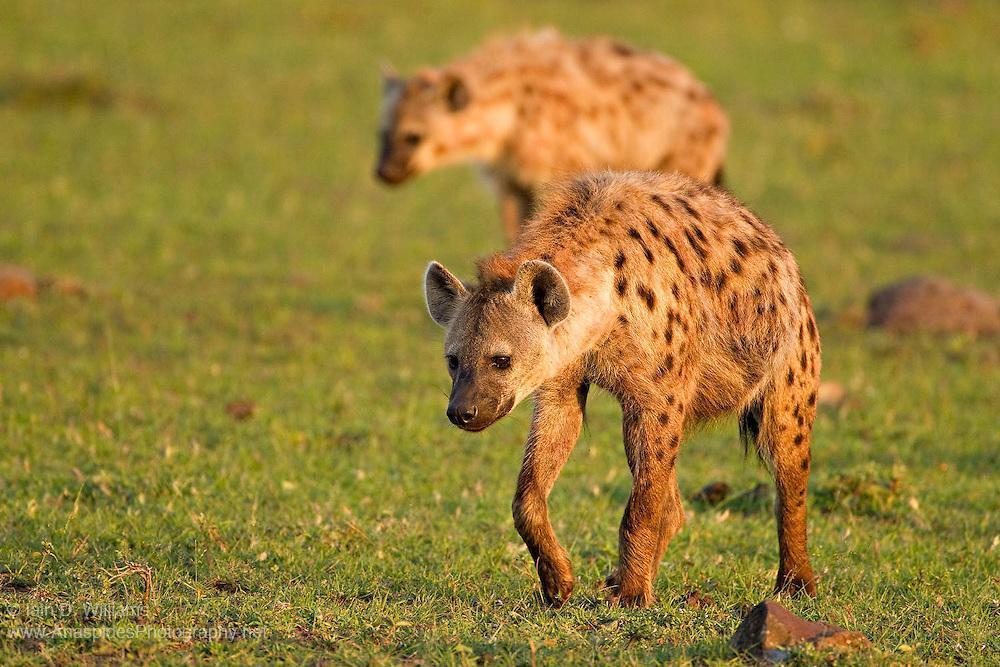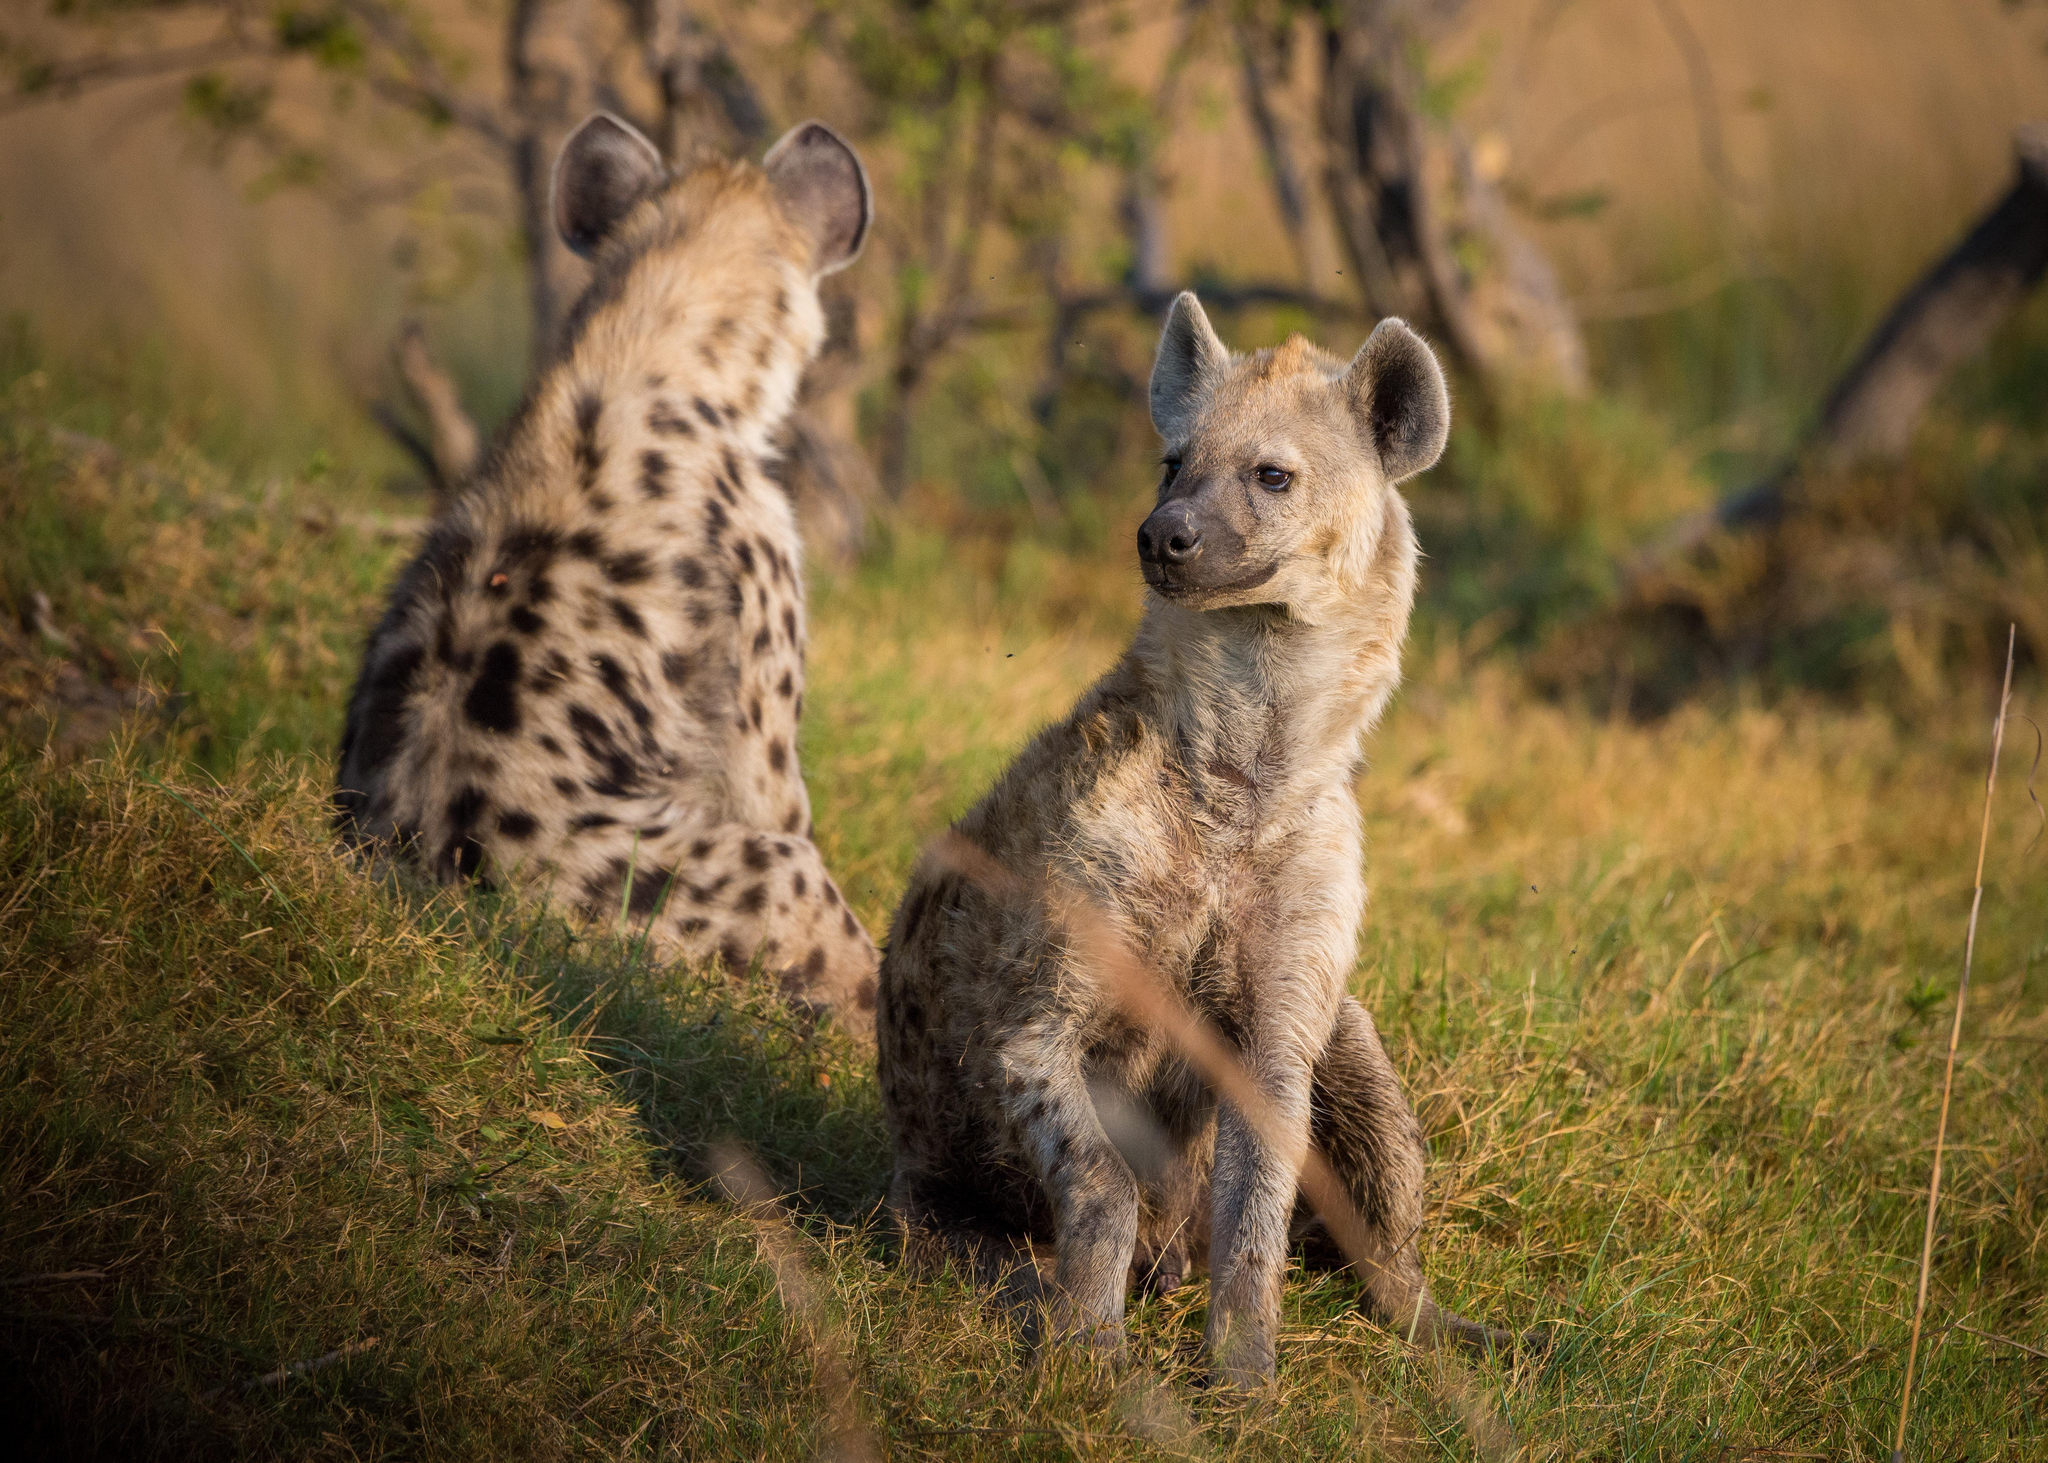The first image is the image on the left, the second image is the image on the right. Given the left and right images, does the statement "An image shows an open-mouthed lion next to at least one hyena." hold true? Answer yes or no. No. The first image is the image on the left, the second image is the image on the right. For the images shown, is this caption "There are two hyenas in one of the images, and a lion near one or more hyenas in the other." true? Answer yes or no. No. 